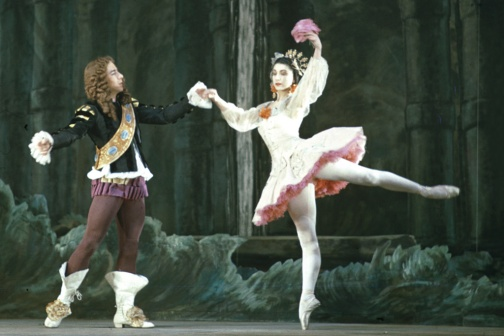How does the background contribute to the overall feel of the performance? The background, resembling a rocky, cave-like setting, significantly heightens the sense of drama and mystique in the performance. It contrasts sharply with the delicate, graceful figures of the dancers, thereby emphasizing their movements and making them stand out. The somber and rugged nature of the environment provides a perfect foil for their elegance, suggesting themes of overcoming obstacles or thriving despite adversity. The texture and darkness of the cave hint at hidden depths and untold stories, contributing to a captivating and immersive atmosphere that draws the viewer into the ballet's emotional world. 